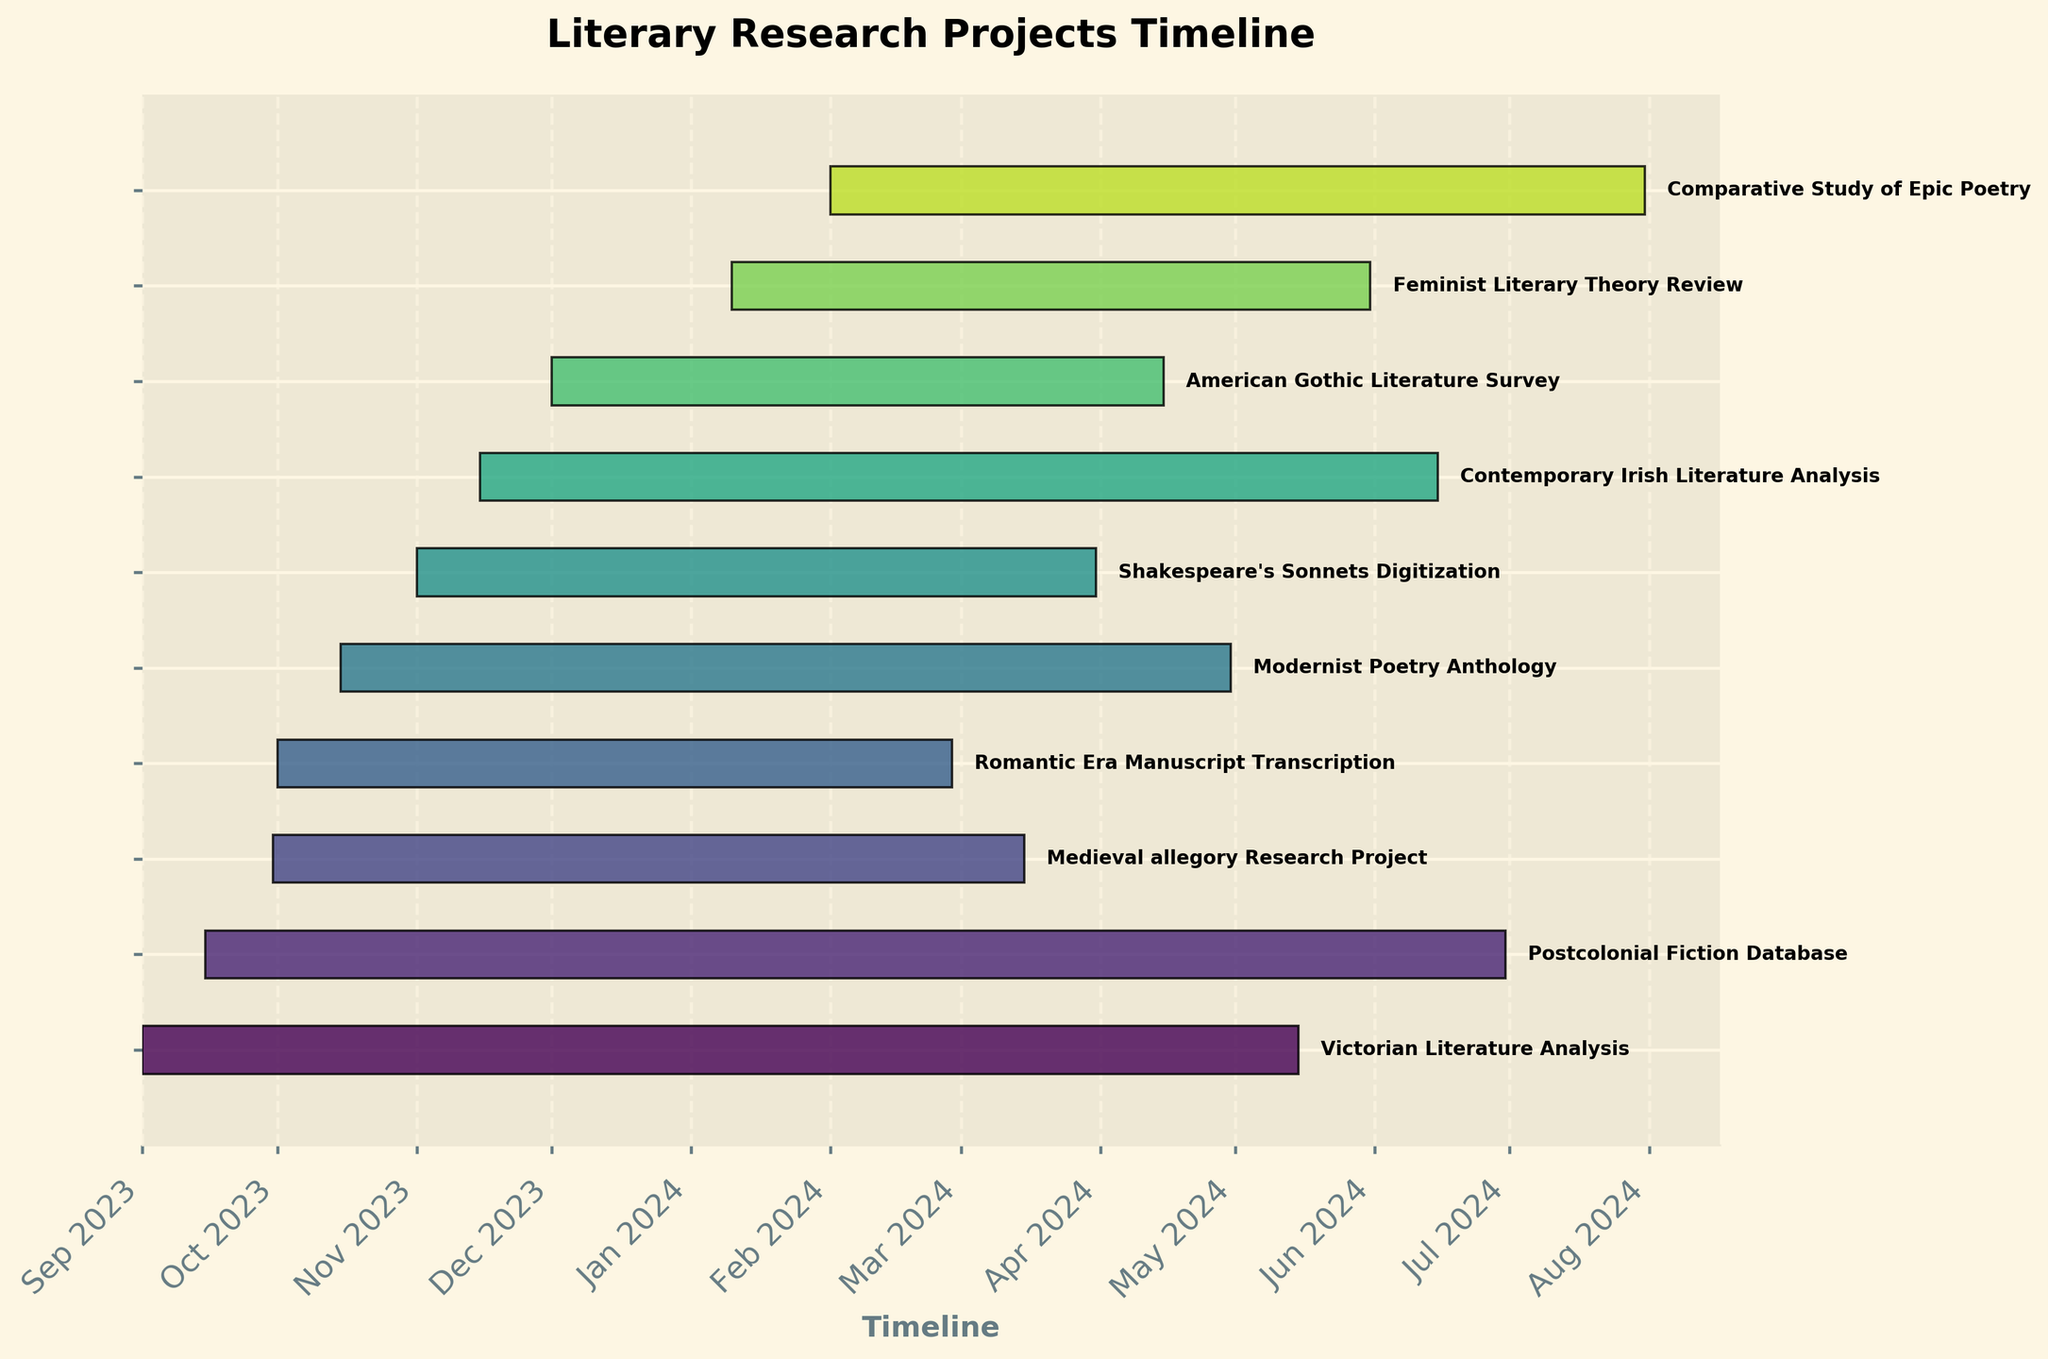What is the title of the Gantt Chart? The title is usually placed at the top of the chart. By examining the topmost part of the chart, we can see the title clearly.
Answer: Literary Research Projects Timeline When does the latest project, in terms of start date, begin? The Gantt bars are aligned horizontally, and the projects start from the top to the bottom, sorted by their start dates. By checking the bottommost bar, we see the "Comparative Study of Epic Poetry" starts on Feb 1, 2024.
Answer: Feb 1, 2024 Which project ends first, and when? We look at the bars' end dates extending from left to right. The shortest bar in terms of the end date represents the "Romantic Era Manuscript Transcription," which ends on Feb 28, 2024.
Answer: Romantic Era Manuscript Transcription, Feb 28, 2024 Which project has the longest duration? To determine the project with the longest duration, check the length of each horizontal bar. The "Postcolonial Fiction Database" bar extends the farthest from its start date to June 30, 2024.
Answer: Postcolonial Fiction Database How many projects start before October 2023? By counting the bars starting in September 2023, we see the "Victorian Literature Analysis," "Postcolonial Fiction Database," and "Medieval allegory Research Project" start before October 2023.
Answer: 3 Which projects are ongoing at the beginning of 2024? To see which projects span across the timeline into January 2024, observe all bars crossing from 2023 into 2024. The projects are: "Victorian Literature Analysis," "Modernist Poetry Anthology," "Shakespeare's Sonnets Digitization," "Postcolonial Fiction Database," "American Gothic Literature Survey," "Romantic Era Manuscript Transcription," "Contemporary Irish Literature Analysis," and "Medieval allegory Research Project."
Answer: 8 How many projects are scheduled to be active in April 2024? We need to check which projects have their bars crossing the point of April 2024. By counting these bars, we find 6 projects active: "Victorian Literature Analysis," "Modernist Poetry Anthology," "Shakespeare's Sonnets Digitization," "American Gothic Literature Survey," "Contemporary Irish Literature Analysis," and "Postcolonial Fiction Database."
Answer: 6 Which two projects have the shortest duration, and what are their durations? The shortest bars on the chart represent projects with the shortest duration. "Romantic Era Manuscript Transcription" and "Medieval allegory Research Project," both of which are approximately 150 and 167 days long, respectively.
Answer: Romantic Era Manuscript Transcription: 150 days, Medieval allegory Research Project: 167 days Which project spans from September 2023 to March 2024? Look for bars that start in September 2023 and end in March 2024. The "Medieval allegory Research Project" fits this timeline.
Answer: Medieval allegory Research Project 